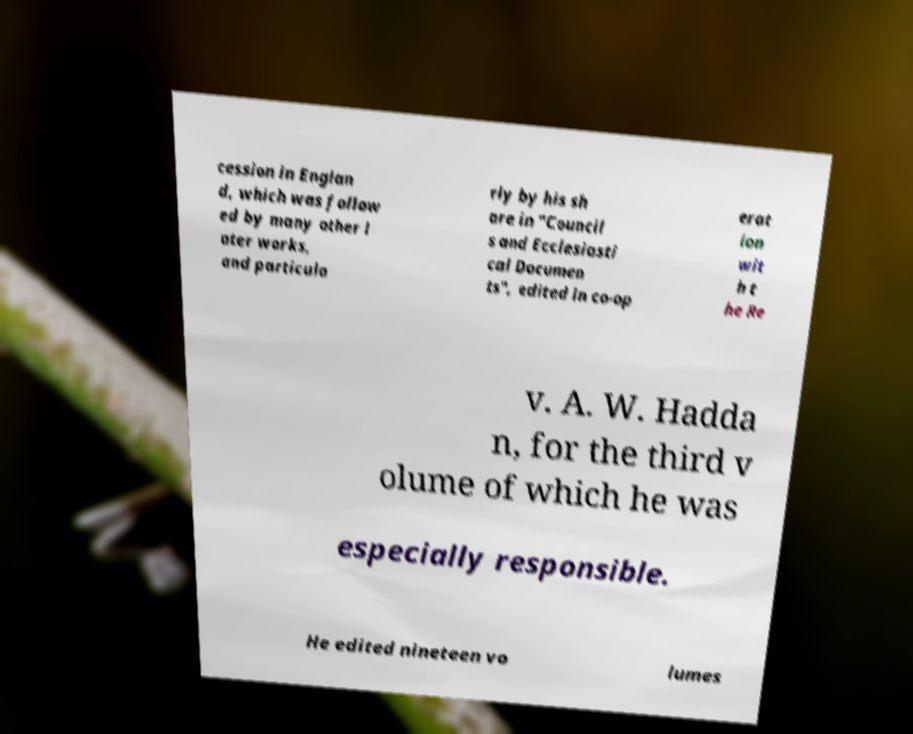There's text embedded in this image that I need extracted. Can you transcribe it verbatim? cession in Englan d, which was follow ed by many other l ater works, and particula rly by his sh are in "Council s and Ecclesiasti cal Documen ts", edited in co-op erat ion wit h t he Re v. A. W. Hadda n, for the third v olume of which he was especially responsible. He edited nineteen vo lumes 